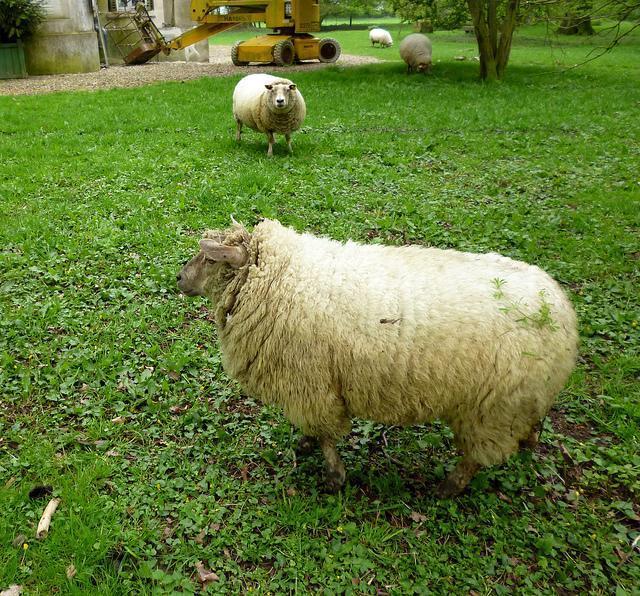How many sheep are there?
Give a very brief answer. 4. How many sheep?
Give a very brief answer. 4. How many sheep are in the photo?
Give a very brief answer. 2. 